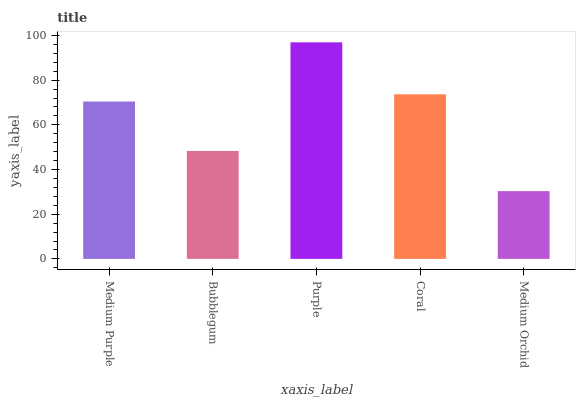Is Medium Orchid the minimum?
Answer yes or no. Yes. Is Purple the maximum?
Answer yes or no. Yes. Is Bubblegum the minimum?
Answer yes or no. No. Is Bubblegum the maximum?
Answer yes or no. No. Is Medium Purple greater than Bubblegum?
Answer yes or no. Yes. Is Bubblegum less than Medium Purple?
Answer yes or no. Yes. Is Bubblegum greater than Medium Purple?
Answer yes or no. No. Is Medium Purple less than Bubblegum?
Answer yes or no. No. Is Medium Purple the high median?
Answer yes or no. Yes. Is Medium Purple the low median?
Answer yes or no. Yes. Is Bubblegum the high median?
Answer yes or no. No. Is Purple the low median?
Answer yes or no. No. 